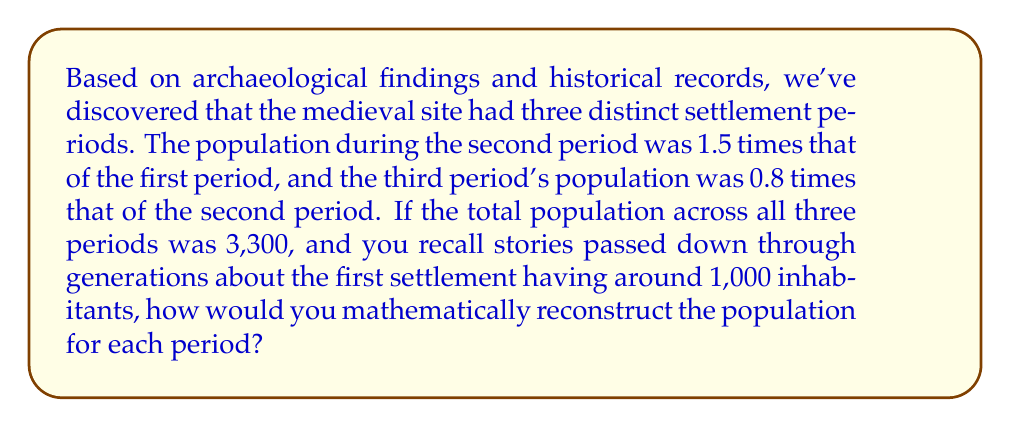Could you help me with this problem? Let's approach this step-by-step:

1) Let $x$ be the population of the first period.

2) Based on the given information:
   - Second period population: $1.5x$
   - Third period population: $0.8(1.5x) = 1.2x$

3) The total population across all three periods is 3,300:
   $$x + 1.5x + 1.2x = 3,300$$

4) Simplify the left side of the equation:
   $$3.7x = 3,300$$

5) Solve for $x$:
   $$x = \frac{3,300}{3.7} \approx 891.89$$

6) Round to the nearest whole number as we're dealing with people:
   First period population: 892

7) Calculate the other periods:
   - Second period: $1.5 * 892 = 1,338$
   - Third period: $1.2 * 892 = 1,070$

8) Verify the total: $892 + 1,338 + 1,070 = 3,300$

9) The oral history suggested around 1,000 inhabitants in the first settlement. Our calculation of 892 is reasonably close to this, considering the potential for slight inaccuracies in oral histories passed down through generations.
Answer: First period: 892; Second period: 1,338; Third period: 1,070 